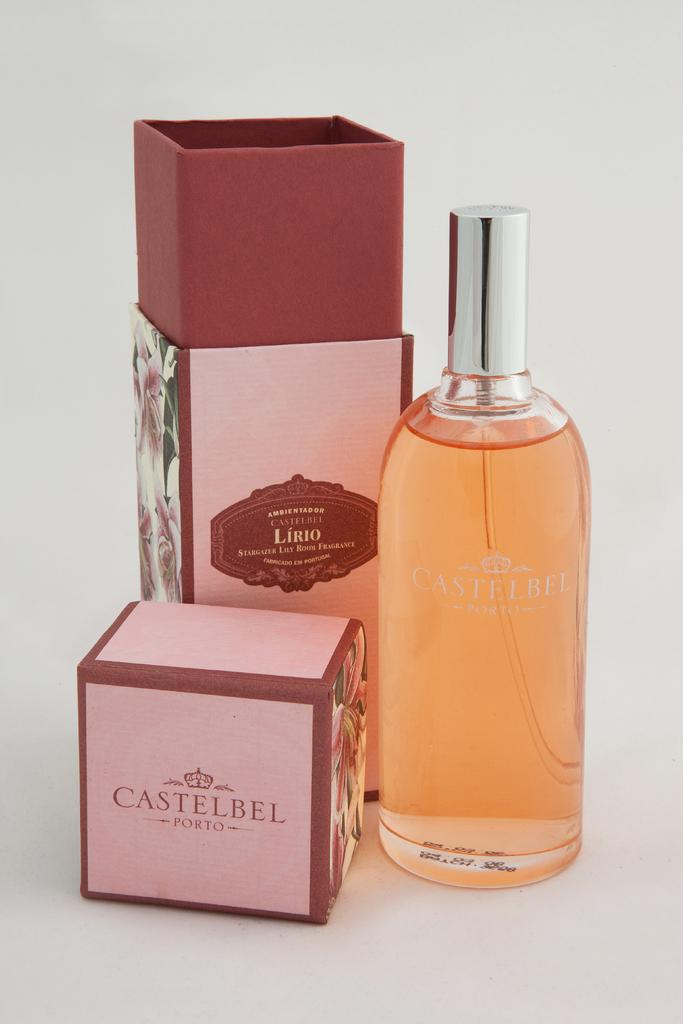What object can be seen in the image? There is a bottle in the image. What is inside the bottle? The bottle contains fluid. What type of shoe is visible in the image? There is no shoe present in the image; it only features a bottle containing fluid. 